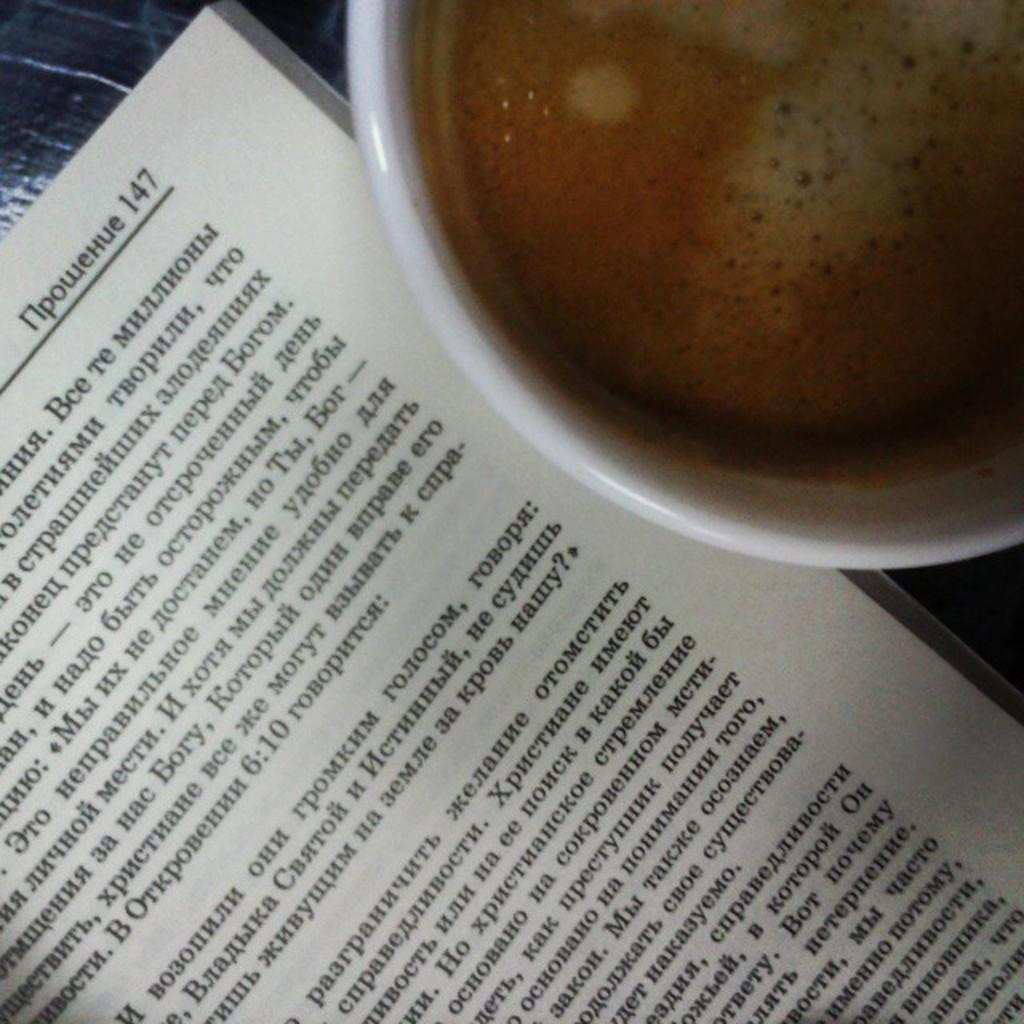<image>
Provide a brief description of the given image. A book open to page 147 next to a mug of coffee. 